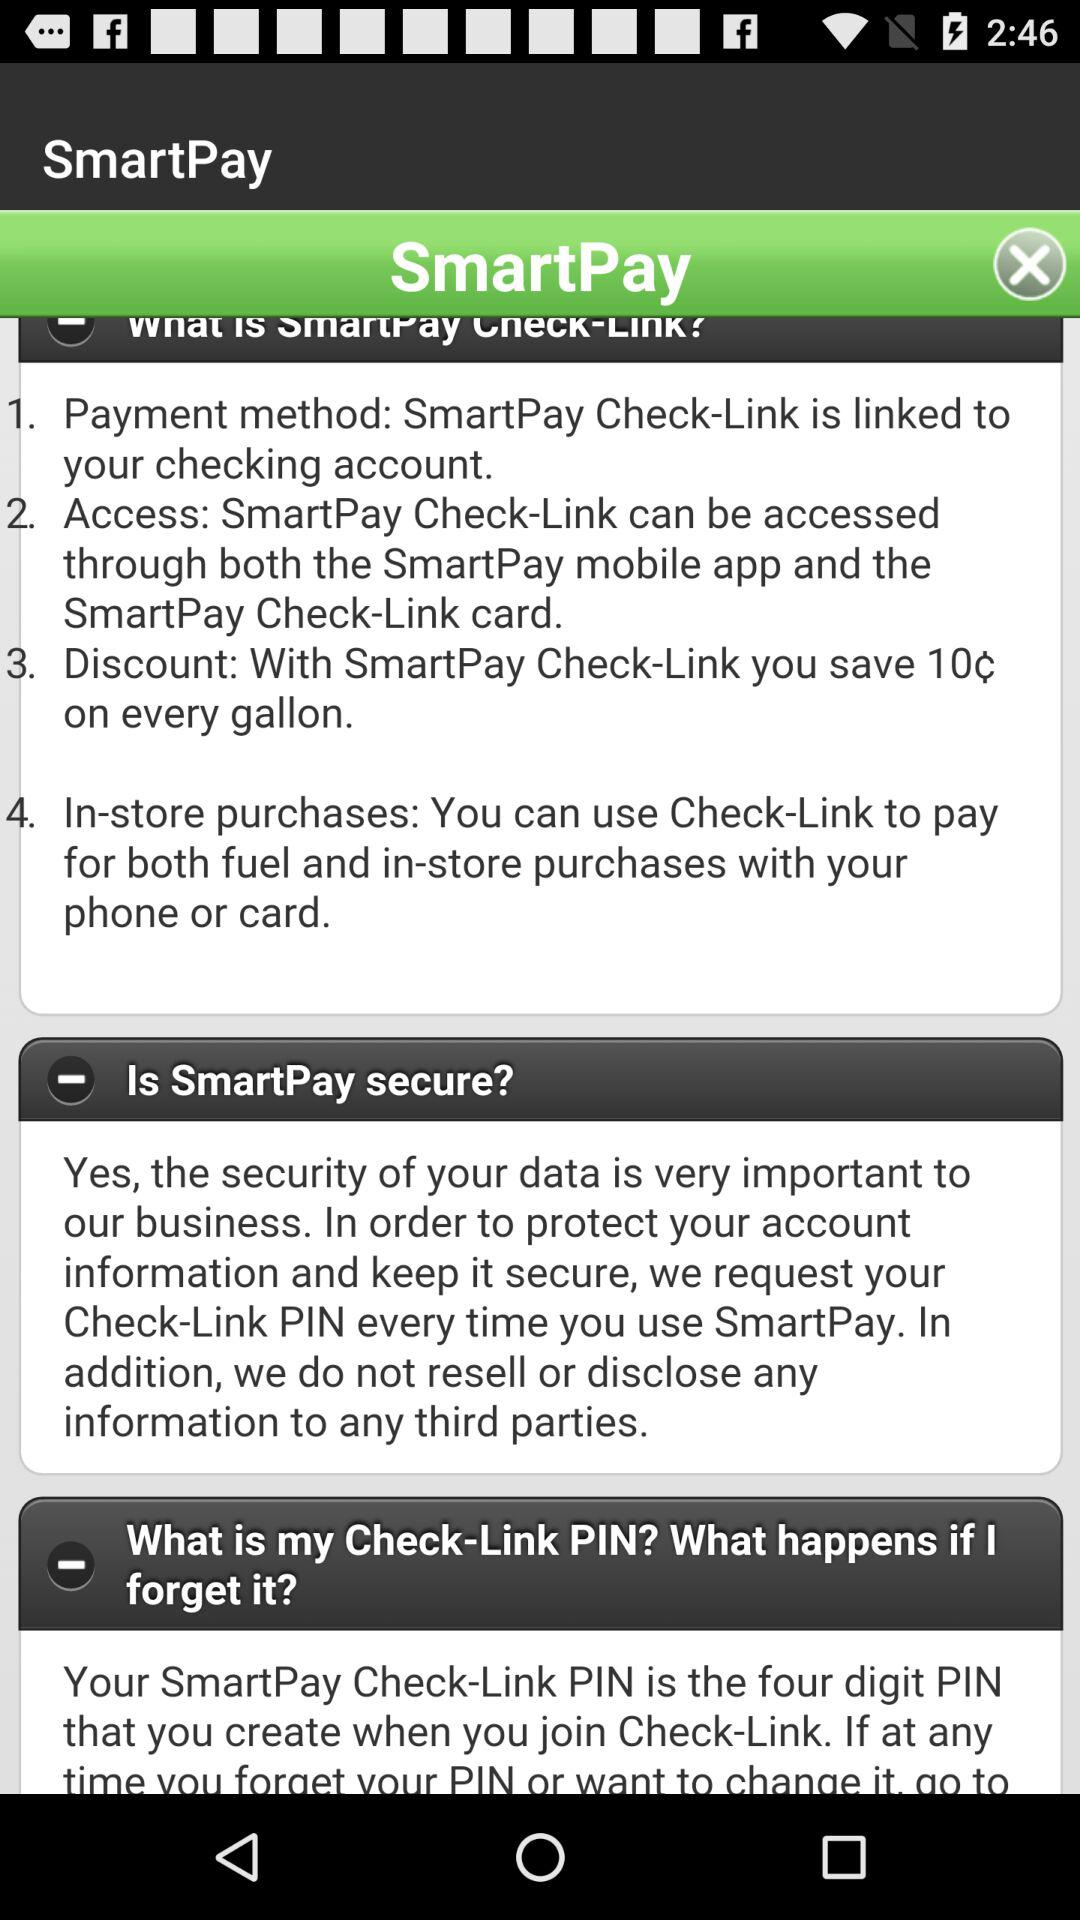What is the amount of the discount on every gallon? The amount of the discount on every gallon is 10 cents. 